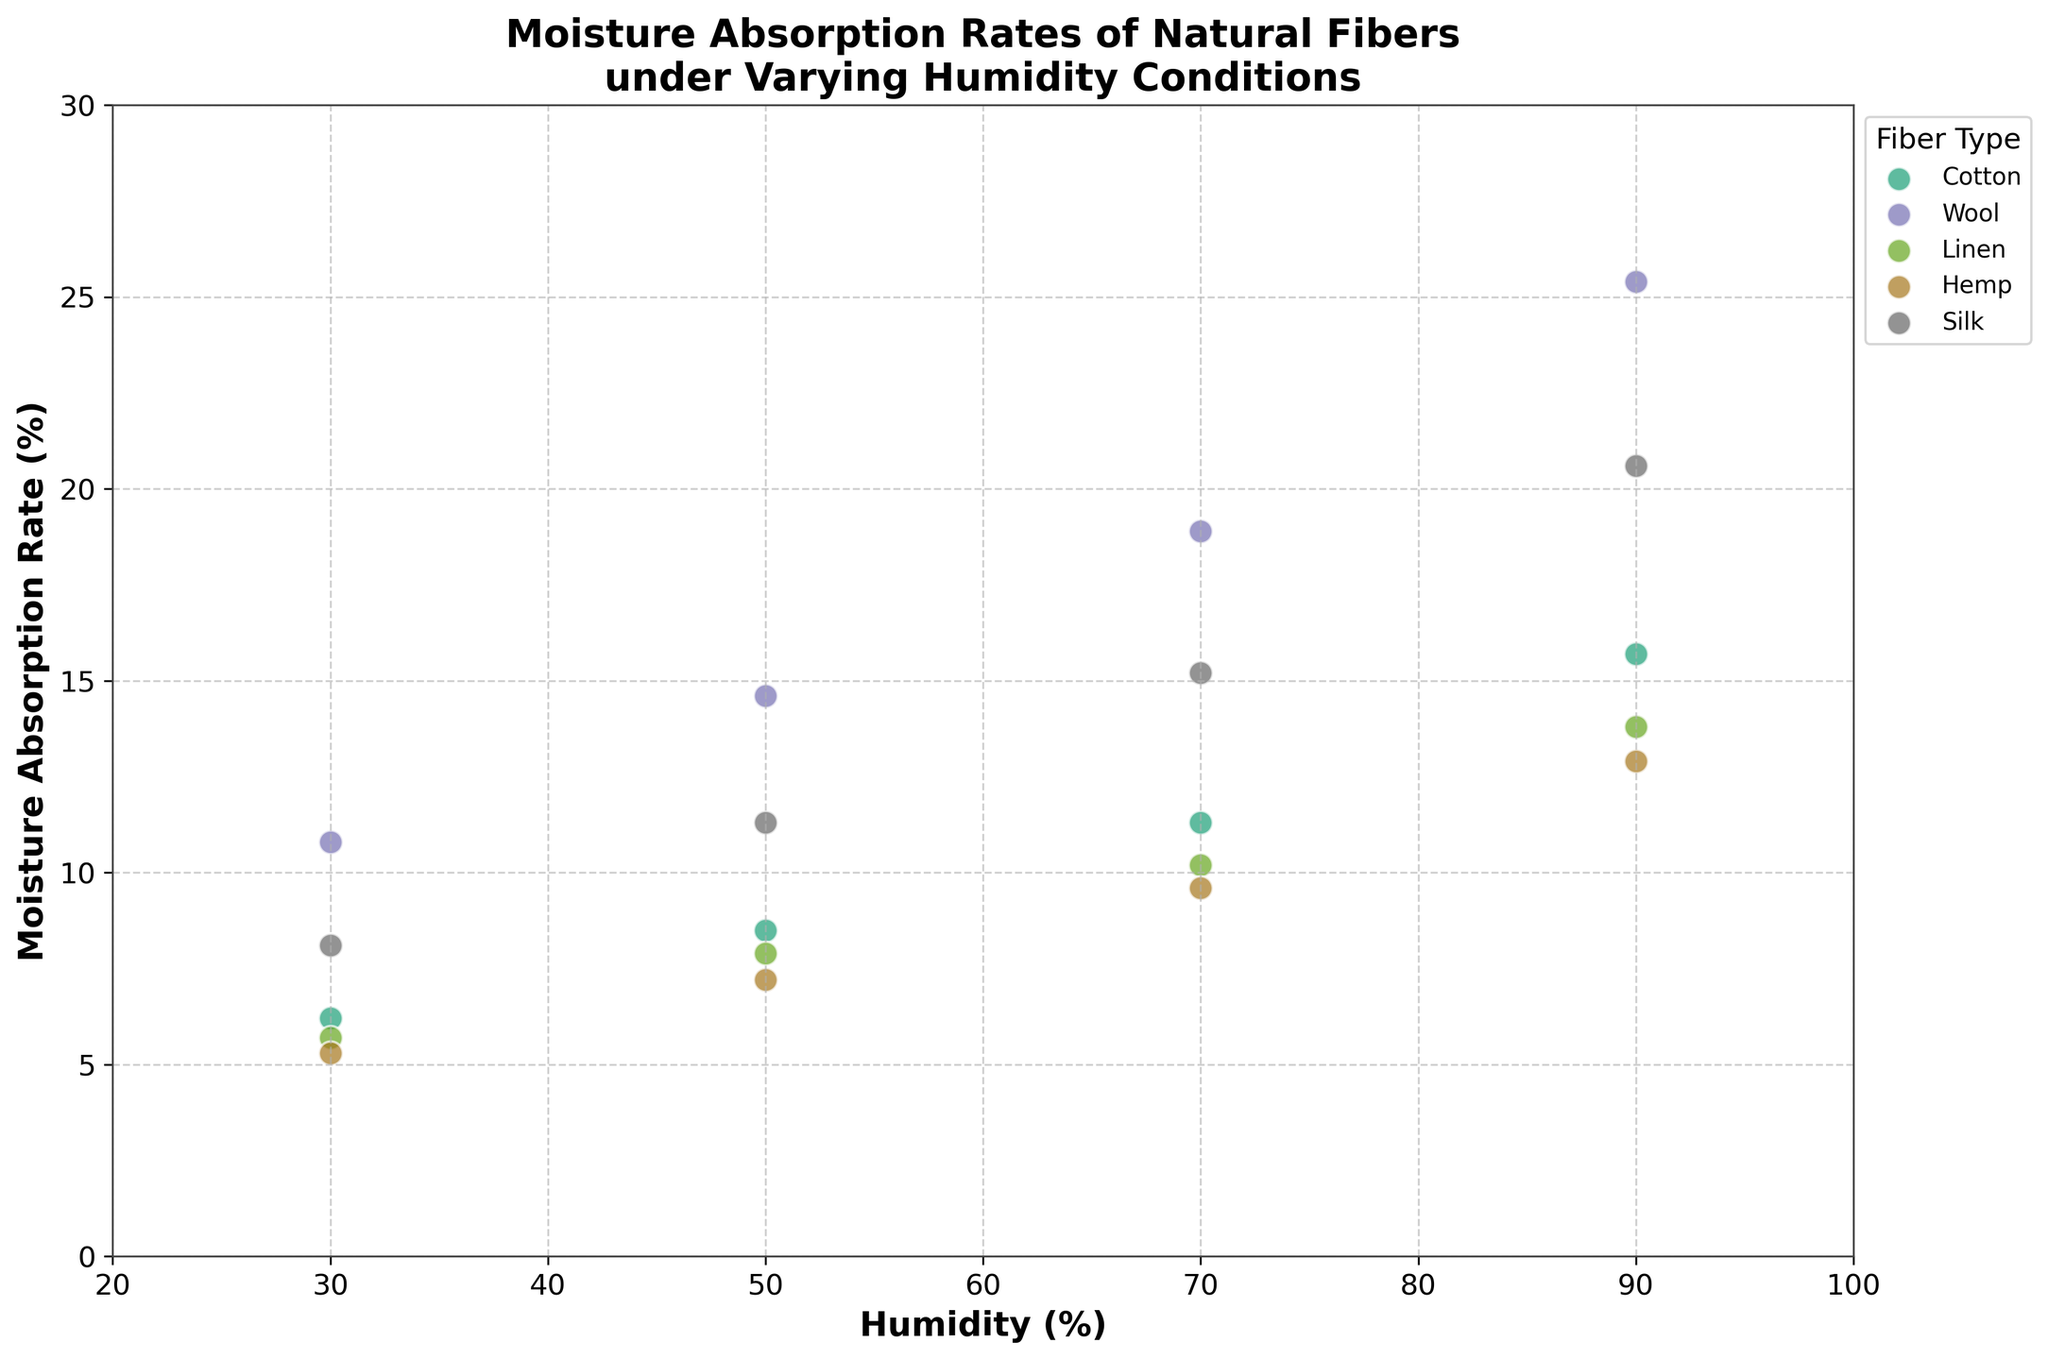What is the title of the figure? The title of the figure can be found at the top of the plot and reads "Moisture Absorption Rates of Natural Fibers under Varying Humidity Conditions".
Answer: Moisture Absorption Rates of Natural Fibers under Varying Humidity Conditions Which fiber absorbs the most moisture at 90% humidity? At 90% humidity, look at the different data points located at 90 on the x-axis. The fiber with the highest moisture absorption rate is Wool, which has the highest y-value at this humidity level.
Answer: Wool What is the moisture absorption rate for Cotton at 50% humidity? Locate the data points for Cotton on the plot, and find the one that aligns with 50 on the x-axis. The corresponding y-value represents the moisture absorption rate.
Answer: 8.5% How does the moisture absorption rate of Silk change from 30% to 90% humidity? Look at the data points for Silk, trace their progression from 30% to 90% humidity on the x-axis, and observe how the y-values increase steadily.
Answer: Increases from 8.1% to 20.6% Compare the moisture absorption rates of Hemp and Linen at 70% humidity. Which fiber absorbs more moisture? Find the data points for Hemp and Linen corresponding to 70% humidity on the x-axis. Compare their y-values to determine which is higher.
Answer: Linen Which fiber shows the least increase in moisture absorption rate as humidity goes from 30% to 90%? Calculate the increase in the moisture absorption rate for each fiber from 30% to 90% humidity. The fiber with the smallest difference has the least increase.
Answer: Hemp What is the average moisture absorption rate for Wool across all humidity levels? Add the moisture absorption rates for Wool at 30%, 50%, 70%, and 90% humidity, then divide by 4 to find the average. (10.8 + 14.6 + 18.9 + 25.4) / 4 = 69.7 / 4 = 17.425
Answer: 17.425% Which fiber types have overlapping data points at any humidity level? Inspect the plot to see if any fibers' data points coincide or are extremely close at any humidity level on the x-axis.
Answer: Cotton and Linen have overlapping points at 50% humidity How do the moisture absorption rates of Cotton and Silk compare at 70% humidity? Look at the data points for Cotton and Silk at 70% humidity and compare their y-values to see which is higher.
Answer: Silk absorbs more moisture What is the range of moisture absorption rates for Linen? Find the maximum and minimum moisture absorption rates for Linen by checking its points on the plot. Subtract the minimum value from the maximum value to get the range. (13.8 - 5.7) = 8.1
Answer: 8.1 